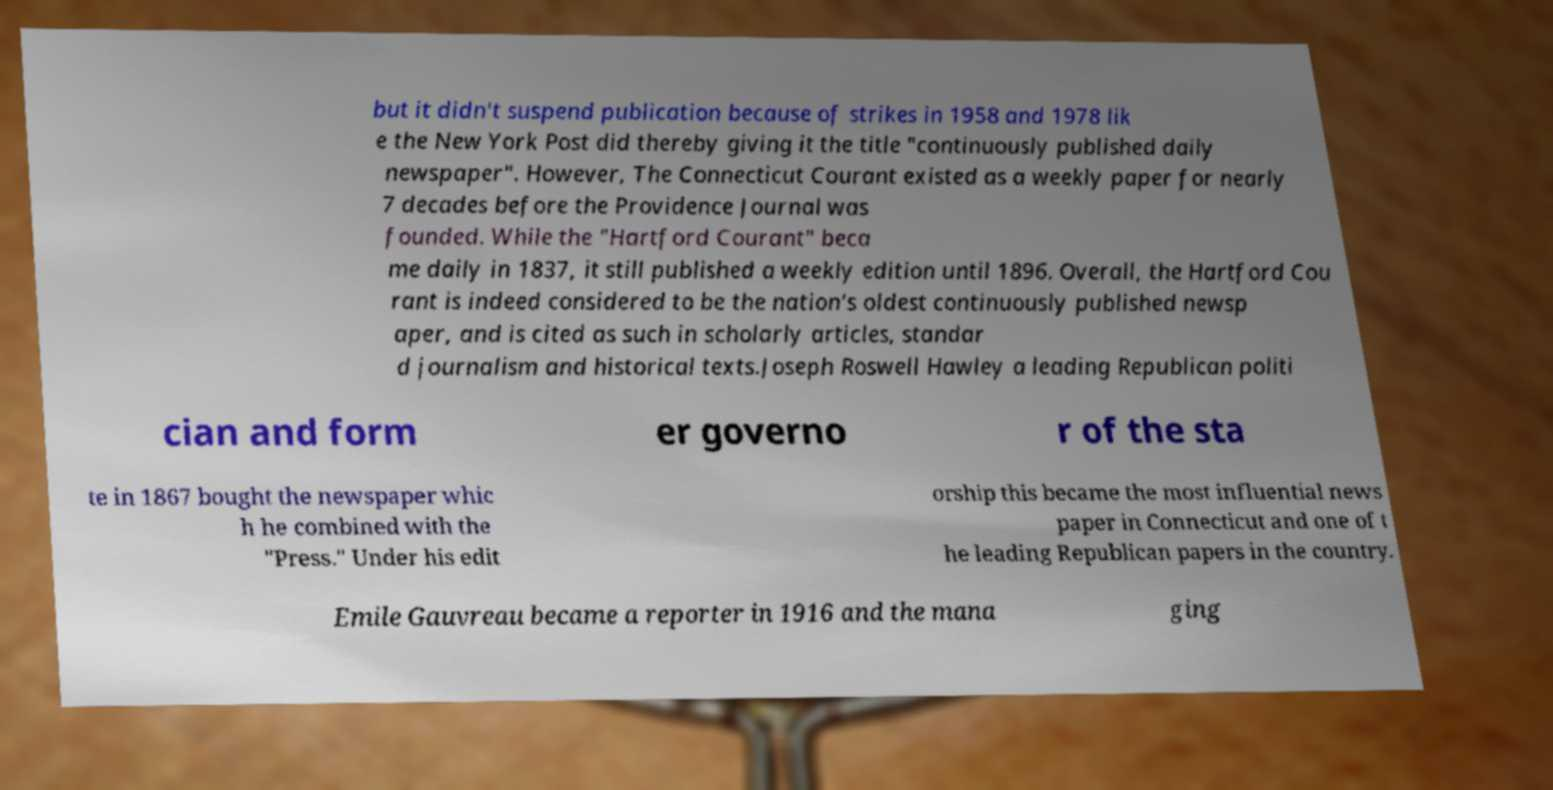Could you extract and type out the text from this image? but it didn't suspend publication because of strikes in 1958 and 1978 lik e the New York Post did thereby giving it the title "continuously published daily newspaper". However, The Connecticut Courant existed as a weekly paper for nearly 7 decades before the Providence Journal was founded. While the "Hartford Courant" beca me daily in 1837, it still published a weekly edition until 1896. Overall, the Hartford Cou rant is indeed considered to be the nation's oldest continuously published newsp aper, and is cited as such in scholarly articles, standar d journalism and historical texts.Joseph Roswell Hawley a leading Republican politi cian and form er governo r of the sta te in 1867 bought the newspaper whic h he combined with the "Press." Under his edit orship this became the most influential news paper in Connecticut and one of t he leading Republican papers in the country. Emile Gauvreau became a reporter in 1916 and the mana ging 